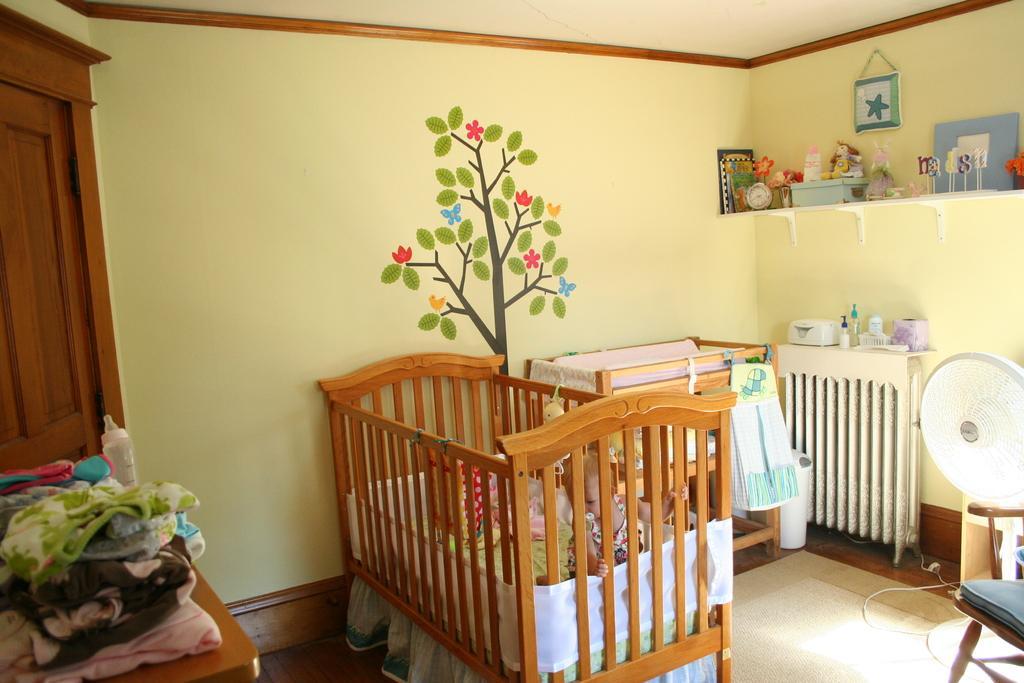Please provide a concise description of this image. In the image there is a baby cradle in the middle with a baby inside it and another baby cradle beside it in front of the wall with plant painting on it, on the left side there is table with some clothes on it with a door beside it, on the right side there is table fan,chair and shelf with some things over it, and above there is another shelf with decorative items on it. 